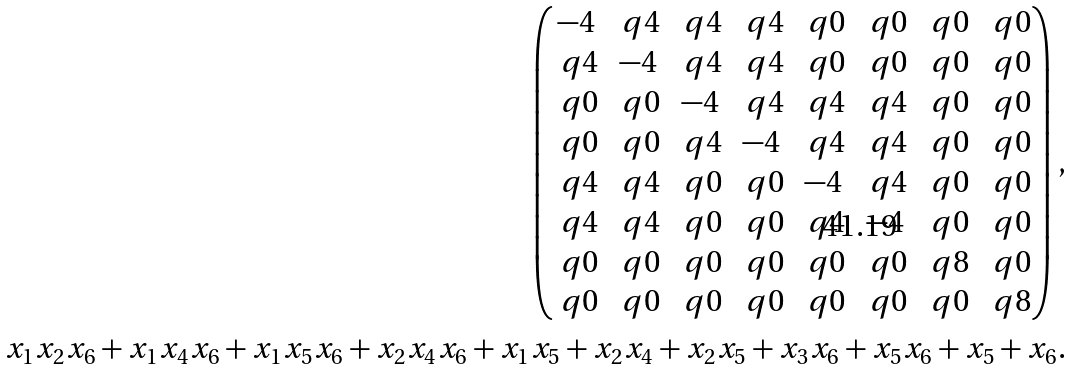<formula> <loc_0><loc_0><loc_500><loc_500>\left ( \begin{matrix} - 4 & \ q 4 & \ q 4 & \ q 4 & \ q 0 & \ q 0 & \ q 0 & \ q 0 \\ \ q 4 & - 4 & \ q 4 & \ q 4 & \ q 0 & \ q 0 & \ q 0 & \ q 0 \\ \ q 0 & \ q 0 & - 4 & \ q 4 & \ q 4 & \ q 4 & \ q 0 & \ q 0 \\ \ q 0 & \ q 0 & \ q 4 & - 4 & \ q 4 & \ q 4 & \ q 0 & \ q 0 \\ \ q 4 & \ q 4 & \ q 0 & \ q 0 & - 4 & \ q 4 & \ q 0 & \ q 0 \\ \ q 4 & \ q 4 & \ q 0 & \ q 0 & \ q 4 & - 4 & \ q 0 & \ q 0 \\ \ q 0 & \ q 0 & \ q 0 & \ q 0 & \ q 0 & \ q 0 & \ q 8 & \ q 0 \\ \ q 0 & \ q 0 & \ q 0 & \ q 0 & \ q 0 & \ q 0 & \ q 0 & \ q 8 \\ \end{matrix} \right ) , \\ x _ { 1 } x _ { 2 } x _ { 6 } + x _ { 1 } x _ { 4 } x _ { 6 } + x _ { 1 } x _ { 5 } x _ { 6 } + x _ { 2 } x _ { 4 } x _ { 6 } + x _ { 1 } x _ { 5 } + x _ { 2 } x _ { 4 } + x _ { 2 } x _ { 5 } + x _ { 3 } x _ { 6 } + x _ { 5 } x _ { 6 } + x _ { 5 } + x _ { 6 } .</formula> 